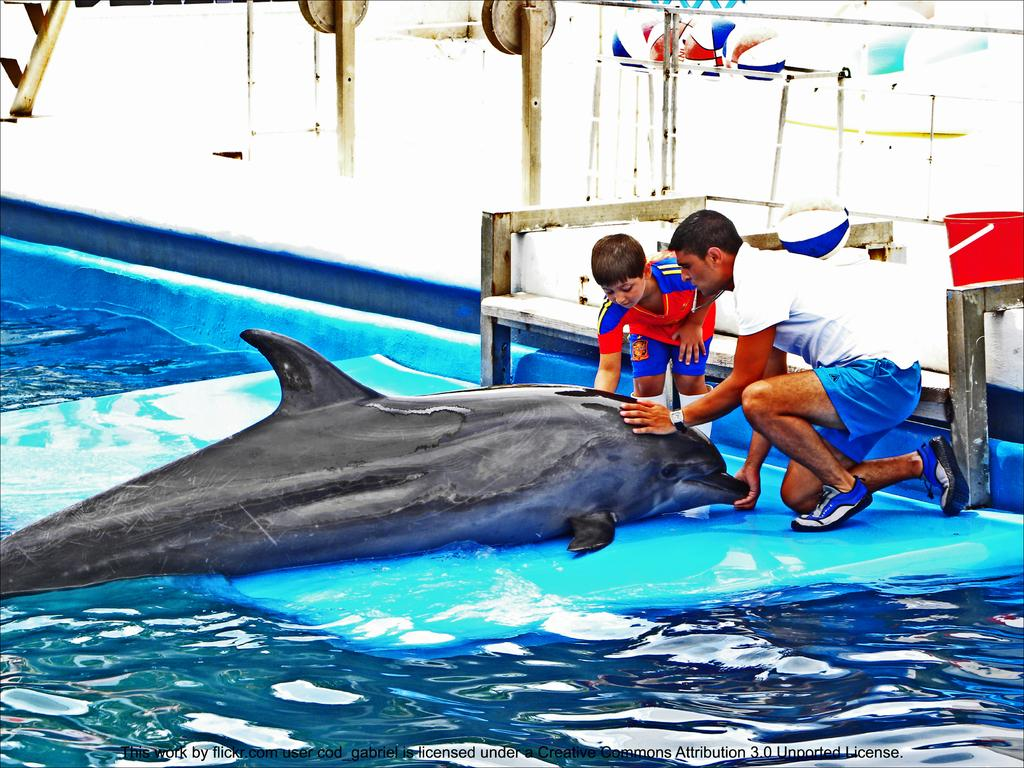Who are the two people in the image? There is a man and a boy in the image. What are they doing in the image? Both the man and the boy are touching a shark in the water. What can be seen in the background of the image? There is a bench, a bucket, and wooden sticks in the background of the image. How would you describe the quality of the image? The image is blurry. What type of yarn is being used to create the shark in the image? There is no yarn present in the image; the shark is a real animal in the water. 